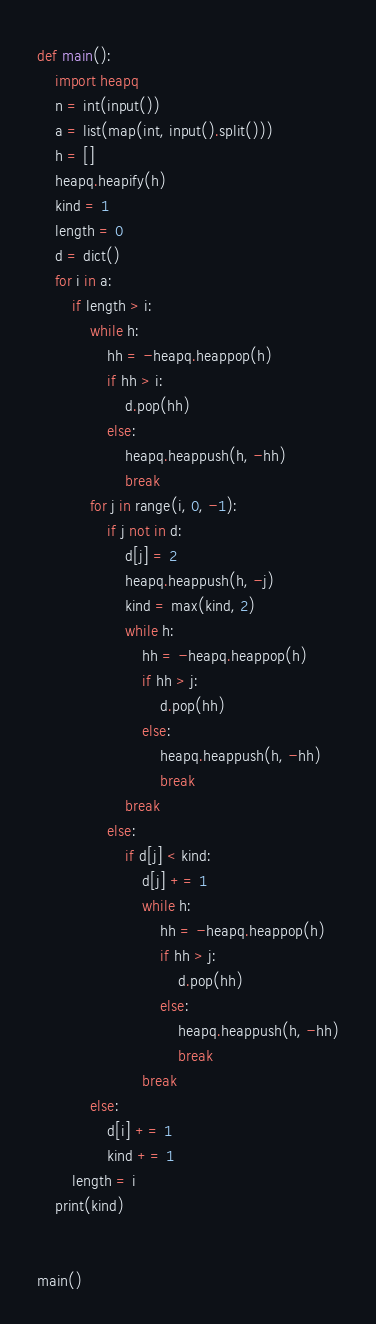<code> <loc_0><loc_0><loc_500><loc_500><_Python_>def main():
    import heapq
    n = int(input())
    a = list(map(int, input().split()))
    h = []
    heapq.heapify(h)
    kind = 1
    length = 0
    d = dict()
    for i in a:
        if length > i:
            while h:
                hh = -heapq.heappop(h)
                if hh > i:
                    d.pop(hh)
                else:
                    heapq.heappush(h, -hh)
                    break
            for j in range(i, 0, -1):
                if j not in d:
                    d[j] = 2
                    heapq.heappush(h, -j)
                    kind = max(kind, 2)
                    while h:
                        hh = -heapq.heappop(h)
                        if hh > j:
                            d.pop(hh)
                        else:
                            heapq.heappush(h, -hh)
                            break
                    break
                else:
                    if d[j] < kind:
                        d[j] += 1
                        while h:
                            hh = -heapq.heappop(h)
                            if hh > j:
                                d.pop(hh)
                            else:
                                heapq.heappush(h, -hh)
                                break
                        break
            else:
                d[i] += 1
                kind += 1
        length = i
    print(kind)


main()
</code> 